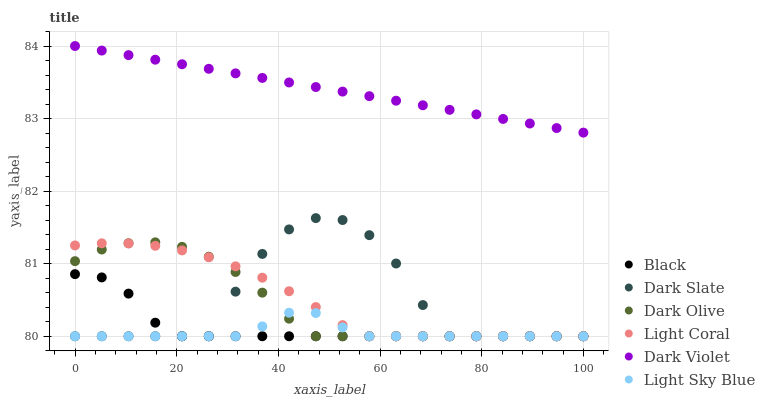Does Light Sky Blue have the minimum area under the curve?
Answer yes or no. Yes. Does Dark Violet have the maximum area under the curve?
Answer yes or no. Yes. Does Light Coral have the minimum area under the curve?
Answer yes or no. No. Does Light Coral have the maximum area under the curve?
Answer yes or no. No. Is Dark Violet the smoothest?
Answer yes or no. Yes. Is Dark Slate the roughest?
Answer yes or no. Yes. Is Light Coral the smoothest?
Answer yes or no. No. Is Light Coral the roughest?
Answer yes or no. No. Does Dark Olive have the lowest value?
Answer yes or no. Yes. Does Dark Violet have the lowest value?
Answer yes or no. No. Does Dark Violet have the highest value?
Answer yes or no. Yes. Does Light Coral have the highest value?
Answer yes or no. No. Is Dark Slate less than Dark Violet?
Answer yes or no. Yes. Is Dark Violet greater than Dark Slate?
Answer yes or no. Yes. Does Light Sky Blue intersect Black?
Answer yes or no. Yes. Is Light Sky Blue less than Black?
Answer yes or no. No. Is Light Sky Blue greater than Black?
Answer yes or no. No. Does Dark Slate intersect Dark Violet?
Answer yes or no. No. 